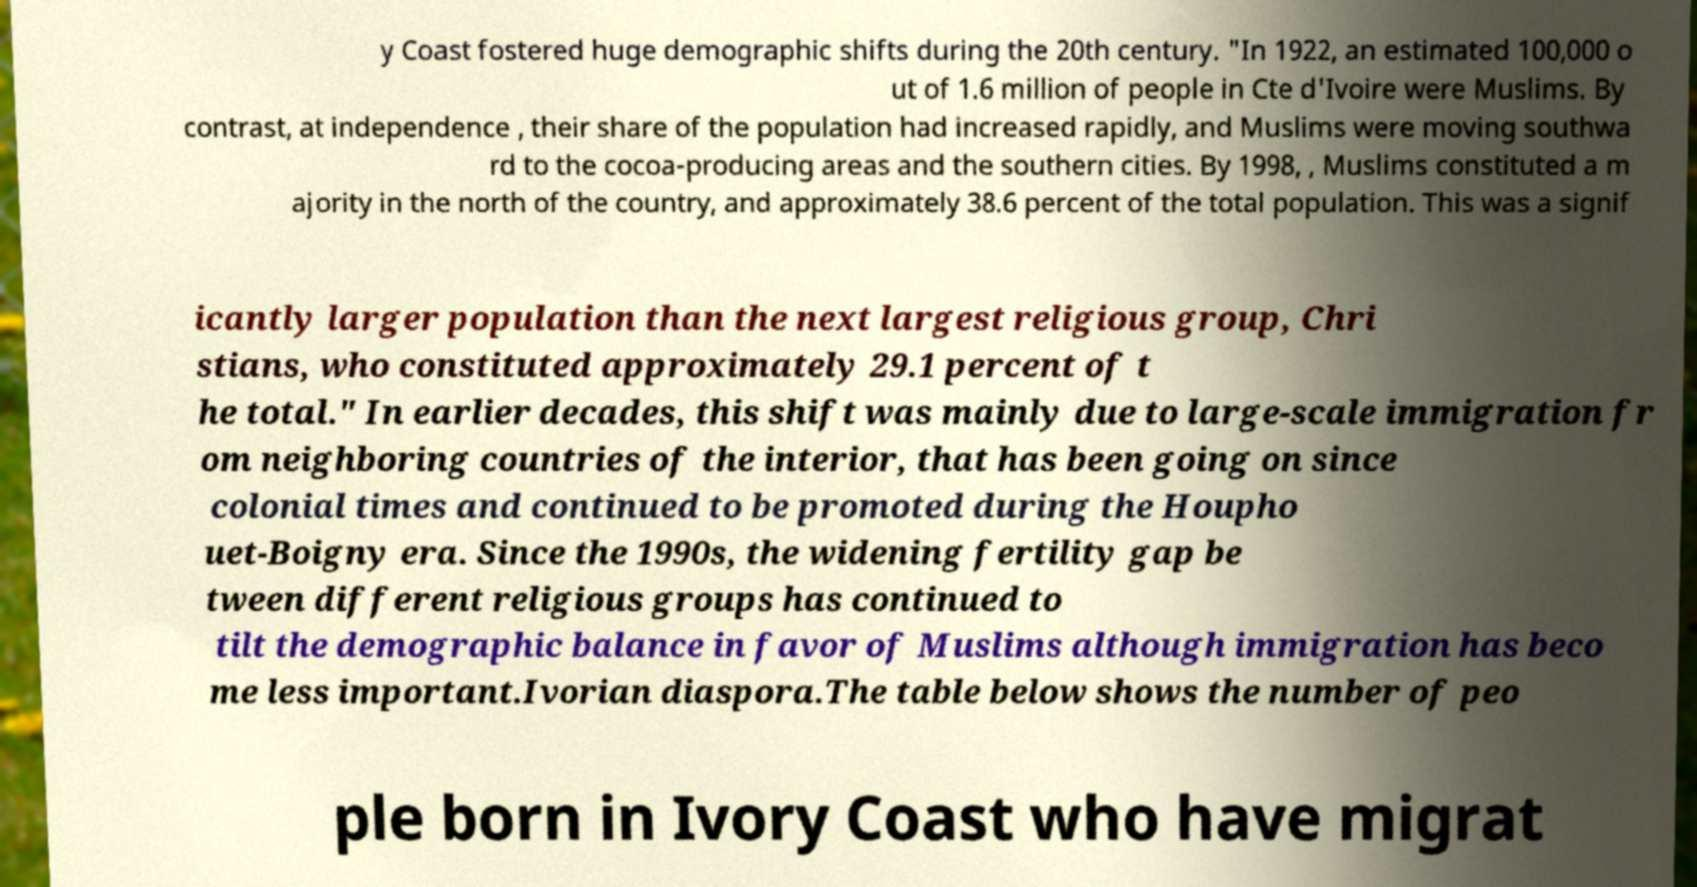There's text embedded in this image that I need extracted. Can you transcribe it verbatim? y Coast fostered huge demographic shifts during the 20th century. "In 1922, an estimated 100,000 o ut of 1.6 million of people in Cte d'Ivoire were Muslims. By contrast, at independence , their share of the population had increased rapidly, and Muslims were moving southwa rd to the cocoa-producing areas and the southern cities. By 1998, , Muslims constituted a m ajority in the north of the country, and approximately 38.6 percent of the total population. This was a signif icantly larger population than the next largest religious group, Chri stians, who constituted approximately 29.1 percent of t he total." In earlier decades, this shift was mainly due to large-scale immigration fr om neighboring countries of the interior, that has been going on since colonial times and continued to be promoted during the Houpho uet-Boigny era. Since the 1990s, the widening fertility gap be tween different religious groups has continued to tilt the demographic balance in favor of Muslims although immigration has beco me less important.Ivorian diaspora.The table below shows the number of peo ple born in Ivory Coast who have migrat 